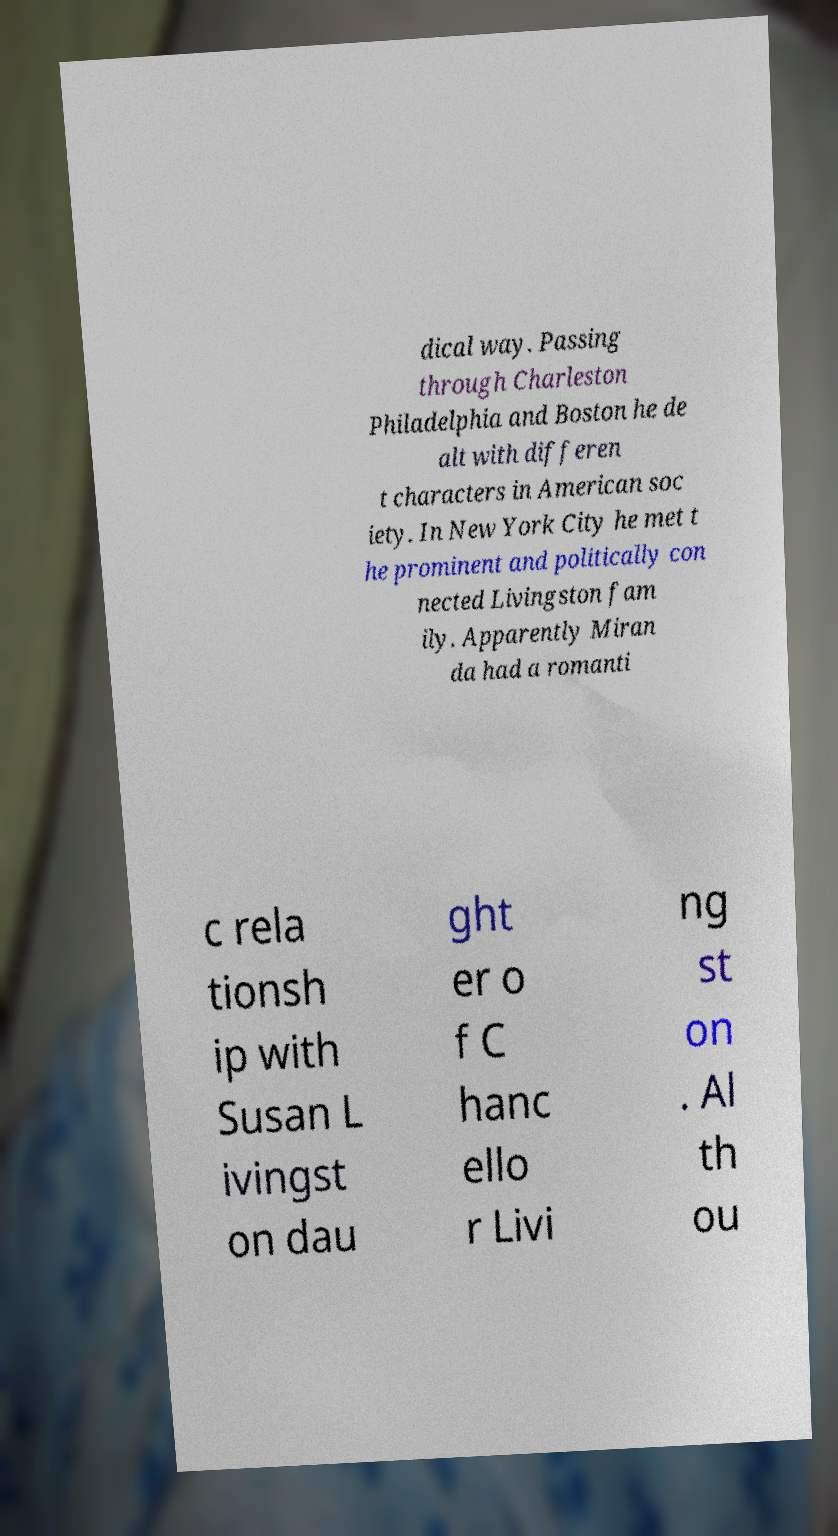For documentation purposes, I need the text within this image transcribed. Could you provide that? dical way. Passing through Charleston Philadelphia and Boston he de alt with differen t characters in American soc iety. In New York City he met t he prominent and politically con nected Livingston fam ily. Apparently Miran da had a romanti c rela tionsh ip with Susan L ivingst on dau ght er o f C hanc ello r Livi ng st on . Al th ou 